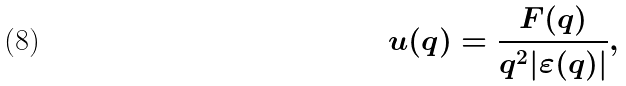<formula> <loc_0><loc_0><loc_500><loc_500>u ( q ) = \frac { F ( q ) } { q ^ { 2 } | \varepsilon ( q ) | } ,</formula> 